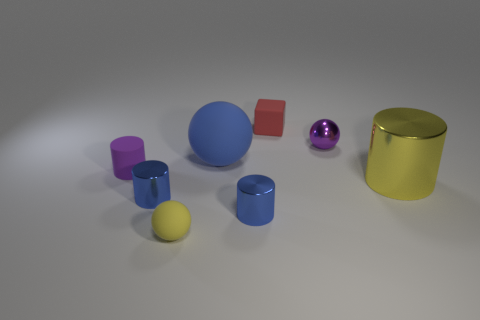Are there any purple matte objects of the same size as the yellow rubber thing?
Provide a succinct answer. Yes. How many big cyan metallic objects are there?
Your answer should be compact. 0. How many large objects are purple rubber blocks or purple objects?
Offer a very short reply. 0. There is a tiny ball that is in front of the tiny sphere that is behind the metallic cylinder on the right side of the tiny matte cube; what is its color?
Keep it short and to the point. Yellow. What number of other objects are there of the same color as the big cylinder?
Your answer should be very brief. 1. How many metal things are yellow cubes or small blue things?
Keep it short and to the point. 2. There is a tiny sphere in front of the blue ball; is it the same color as the large thing that is in front of the purple matte cylinder?
Provide a succinct answer. Yes. There is another rubber object that is the same shape as the tiny yellow matte object; what is its size?
Your response must be concise. Large. Are there more objects that are in front of the red rubber thing than matte cubes?
Provide a short and direct response. Yes. Do the ball to the right of the blue rubber ball and the red cube have the same material?
Offer a very short reply. No. 